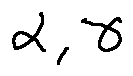<formula> <loc_0><loc_0><loc_500><loc_500>\alpha , \gamma</formula> 